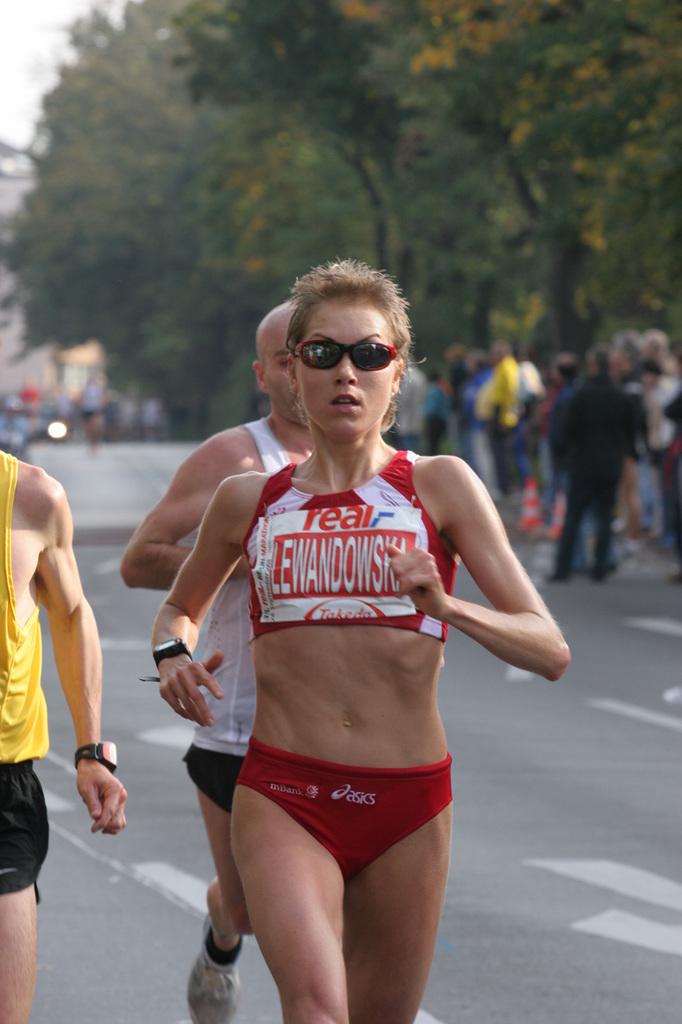What brand of shorts is she wearing?
Offer a very short reply. Asics. What english word is on the woman's sports bra?
Keep it short and to the point. Real. 